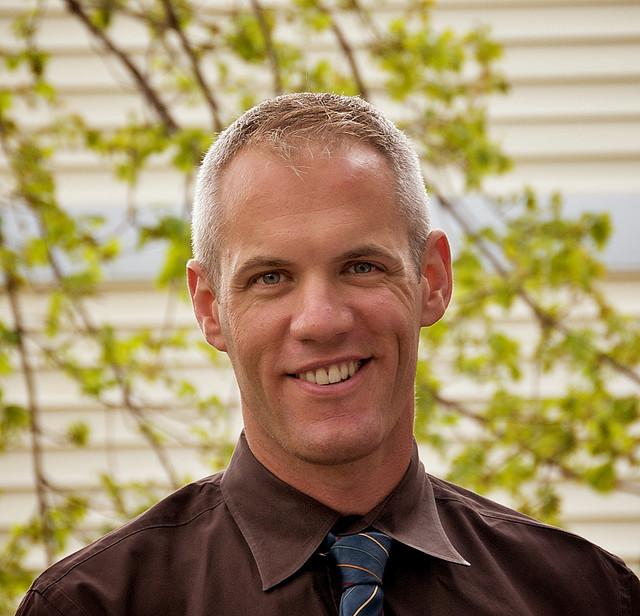What is behind the man?
Quick response, please. Tree. What color is the man's hair?
Quick response, please. Gray. How is this man's posture?
Quick response, please. Good. Does this man look trustworthy?
Answer briefly. Yes. What is his ethnicity?
Write a very short answer. White. What color is this man's shirt?
Give a very brief answer. Brown. 